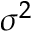<formula> <loc_0><loc_0><loc_500><loc_500>\sigma ^ { 2 }</formula> 